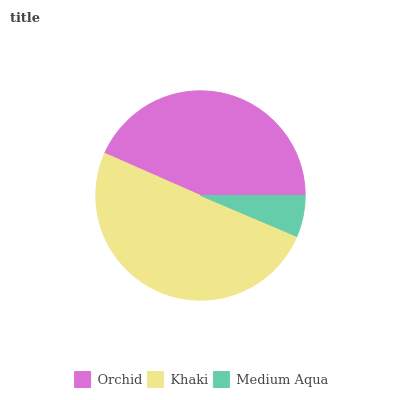Is Medium Aqua the minimum?
Answer yes or no. Yes. Is Khaki the maximum?
Answer yes or no. Yes. Is Khaki the minimum?
Answer yes or no. No. Is Medium Aqua the maximum?
Answer yes or no. No. Is Khaki greater than Medium Aqua?
Answer yes or no. Yes. Is Medium Aqua less than Khaki?
Answer yes or no. Yes. Is Medium Aqua greater than Khaki?
Answer yes or no. No. Is Khaki less than Medium Aqua?
Answer yes or no. No. Is Orchid the high median?
Answer yes or no. Yes. Is Orchid the low median?
Answer yes or no. Yes. Is Khaki the high median?
Answer yes or no. No. Is Khaki the low median?
Answer yes or no. No. 